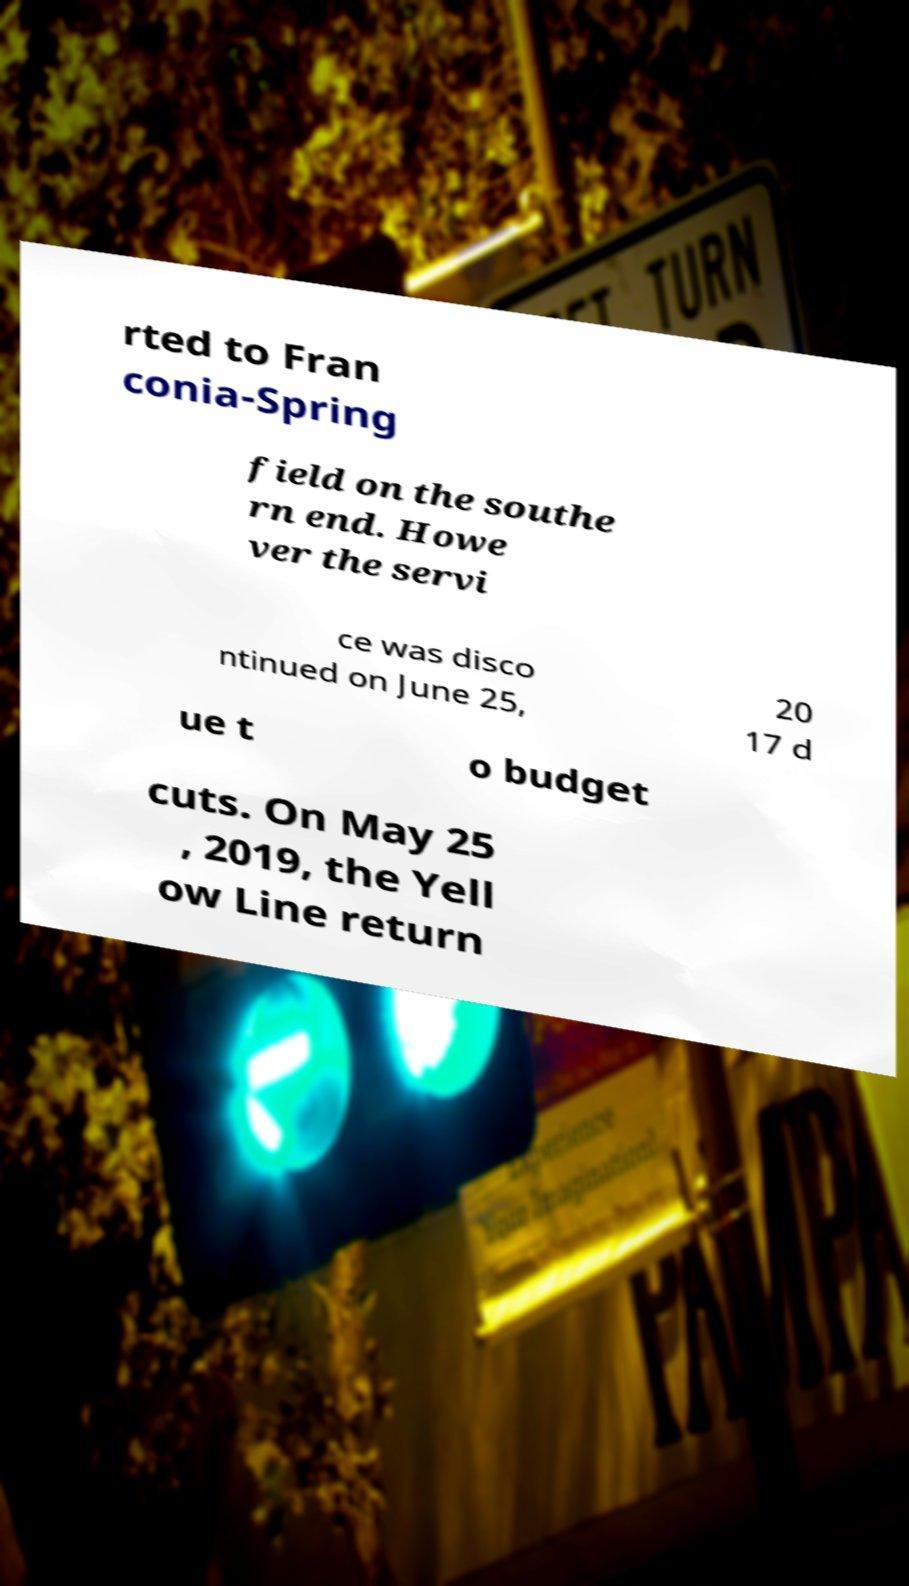What messages or text are displayed in this image? I need them in a readable, typed format. rted to Fran conia-Spring field on the southe rn end. Howe ver the servi ce was disco ntinued on June 25, 20 17 d ue t o budget cuts. On May 25 , 2019, the Yell ow Line return 